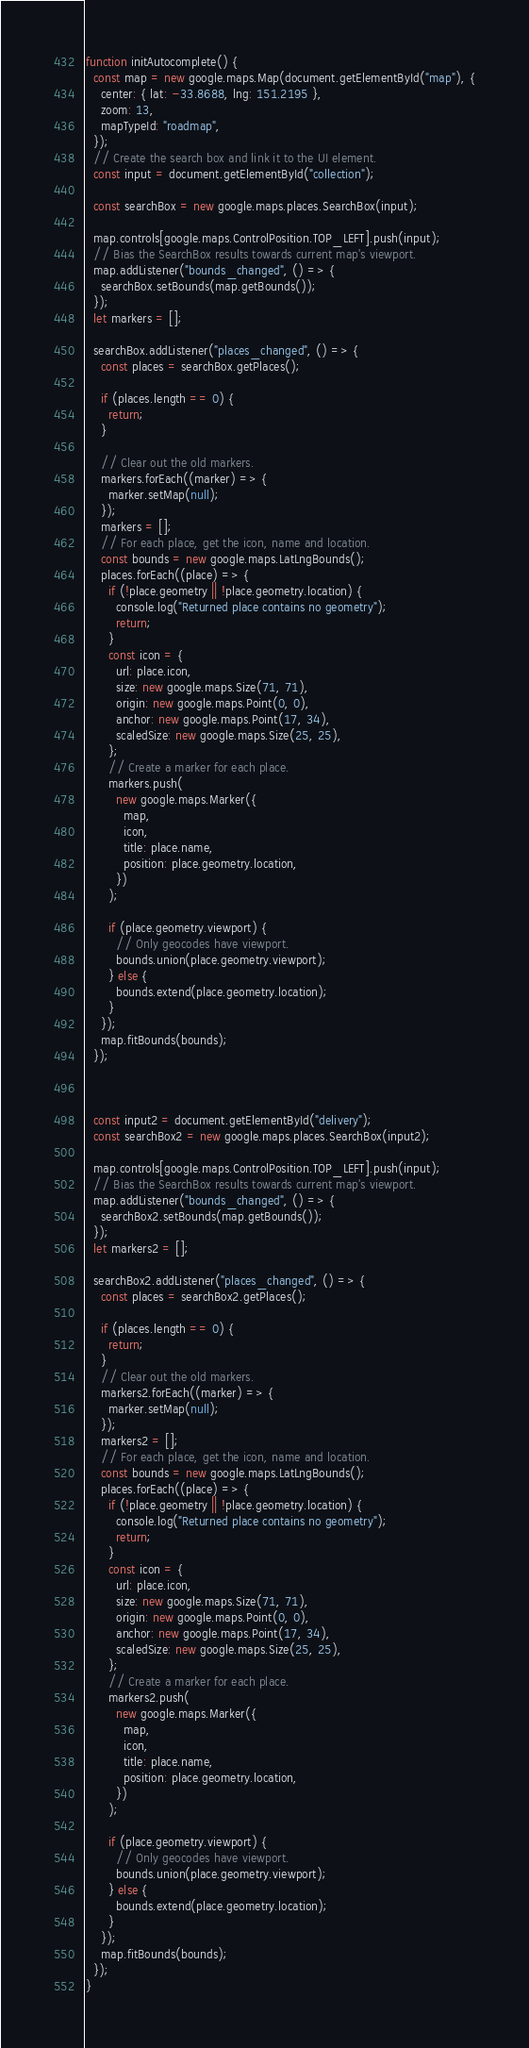<code> <loc_0><loc_0><loc_500><loc_500><_JavaScript_>function initAutocomplete() {
  const map = new google.maps.Map(document.getElementById("map"), {
    center: { lat: -33.8688, lng: 151.2195 },
    zoom: 13,
    mapTypeId: "roadmap",
  });
  // Create the search box and link it to the UI element.
  const input = document.getElementById("collection");
  
  const searchBox = new google.maps.places.SearchBox(input);

  map.controls[google.maps.ControlPosition.TOP_LEFT].push(input);
  // Bias the SearchBox results towards current map's viewport.
  map.addListener("bounds_changed", () => {
    searchBox.setBounds(map.getBounds());
  });
  let markers = [];

  searchBox.addListener("places_changed", () => {
    const places = searchBox.getPlaces();

    if (places.length == 0) {
      return;
    }

    // Clear out the old markers.
    markers.forEach((marker) => {
      marker.setMap(null);
    });
    markers = [];
    // For each place, get the icon, name and location.
    const bounds = new google.maps.LatLngBounds();
    places.forEach((place) => {
      if (!place.geometry || !place.geometry.location) {
        console.log("Returned place contains no geometry");
        return;
      }
      const icon = {
        url: place.icon,
        size: new google.maps.Size(71, 71),
        origin: new google.maps.Point(0, 0),
        anchor: new google.maps.Point(17, 34),
        scaledSize: new google.maps.Size(25, 25),
      };
      // Create a marker for each place.
      markers.push(
        new google.maps.Marker({
          map,
          icon,
          title: place.name,
          position: place.geometry.location,
        })
      );

      if (place.geometry.viewport) {
        // Only geocodes have viewport.
        bounds.union(place.geometry.viewport);
      } else {
        bounds.extend(place.geometry.location);
      }
    });
    map.fitBounds(bounds);
  });



  const input2 = document.getElementById("delivery");
  const searchBox2 = new google.maps.places.SearchBox(input2);

  map.controls[google.maps.ControlPosition.TOP_LEFT].push(input);
  // Bias the SearchBox results towards current map's viewport.
  map.addListener("bounds_changed", () => {
    searchBox2.setBounds(map.getBounds());
  });
  let markers2 = [];

  searchBox2.addListener("places_changed", () => {
    const places = searchBox2.getPlaces();

    if (places.length == 0) {
      return;
    }
    // Clear out the old markers.
    markers2.forEach((marker) => {
      marker.setMap(null);
    });
    markers2 = [];
    // For each place, get the icon, name and location.
    const bounds = new google.maps.LatLngBounds();
    places.forEach((place) => {
      if (!place.geometry || !place.geometry.location) {
        console.log("Returned place contains no geometry");
        return;
      }
      const icon = {
        url: place.icon,
        size: new google.maps.Size(71, 71),
        origin: new google.maps.Point(0, 0),
        anchor: new google.maps.Point(17, 34),
        scaledSize: new google.maps.Size(25, 25),
      };
      // Create a marker for each place.
      markers2.push(
        new google.maps.Marker({
          map,
          icon,
          title: place.name,
          position: place.geometry.location,
        })
      );

      if (place.geometry.viewport) {
        // Only geocodes have viewport.
        bounds.union(place.geometry.viewport);
      } else {
        bounds.extend(place.geometry.location);
      }
    });
    map.fitBounds(bounds);
  });
}</code> 